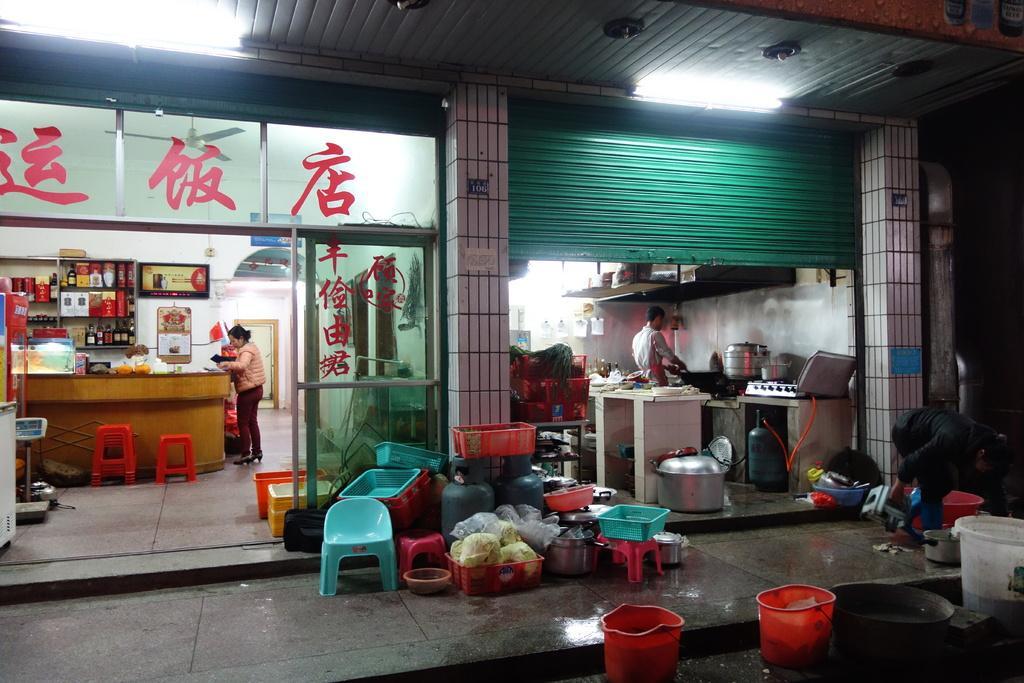Could you give a brief overview of what you see in this image? At the bottom of the image there are buckets. Behind them there is a footpath. On the footpath there is a chair and also there are plastic baskets, cylinders and some other things. On the right side of the image there is a person and also their buckets and vessels. Behind them there is a store. Inside the store there are kitchen platforms with stove, vessels and many other things. And there is a person inside the store. On the left side of the image there is a store with glass walls. On the glasses there is text on it. Inside the store there are stools. Behind the stools there is a table with many items on it. Beside the table there is a lady. Behind the table there on the wall there is a cupboard with items and also there are frames on the wall. At the top of the image there is a ceiling with lights.  